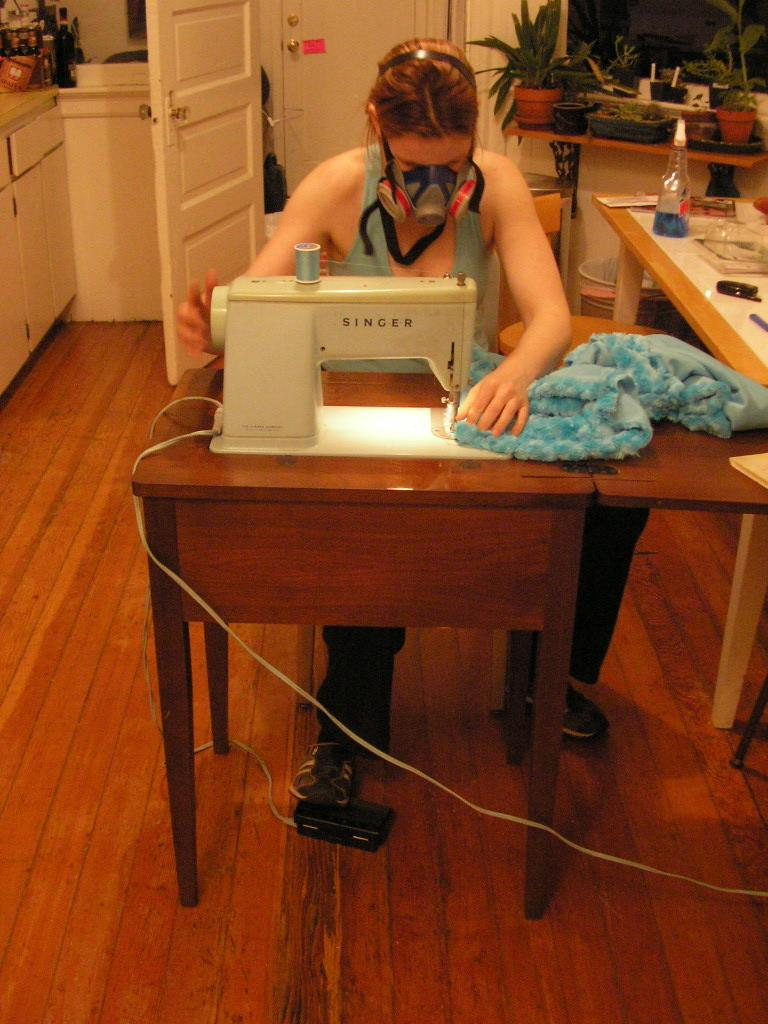Who is the main subject in the image? There is a lady in the image. What is the lady doing in the image? The lady is stitching a blue dress. What can be seen in the background of the image? There is a door and plants in the background of the image. How many cherries are on the boot in the image? There are no cherries or boots present in the image. 